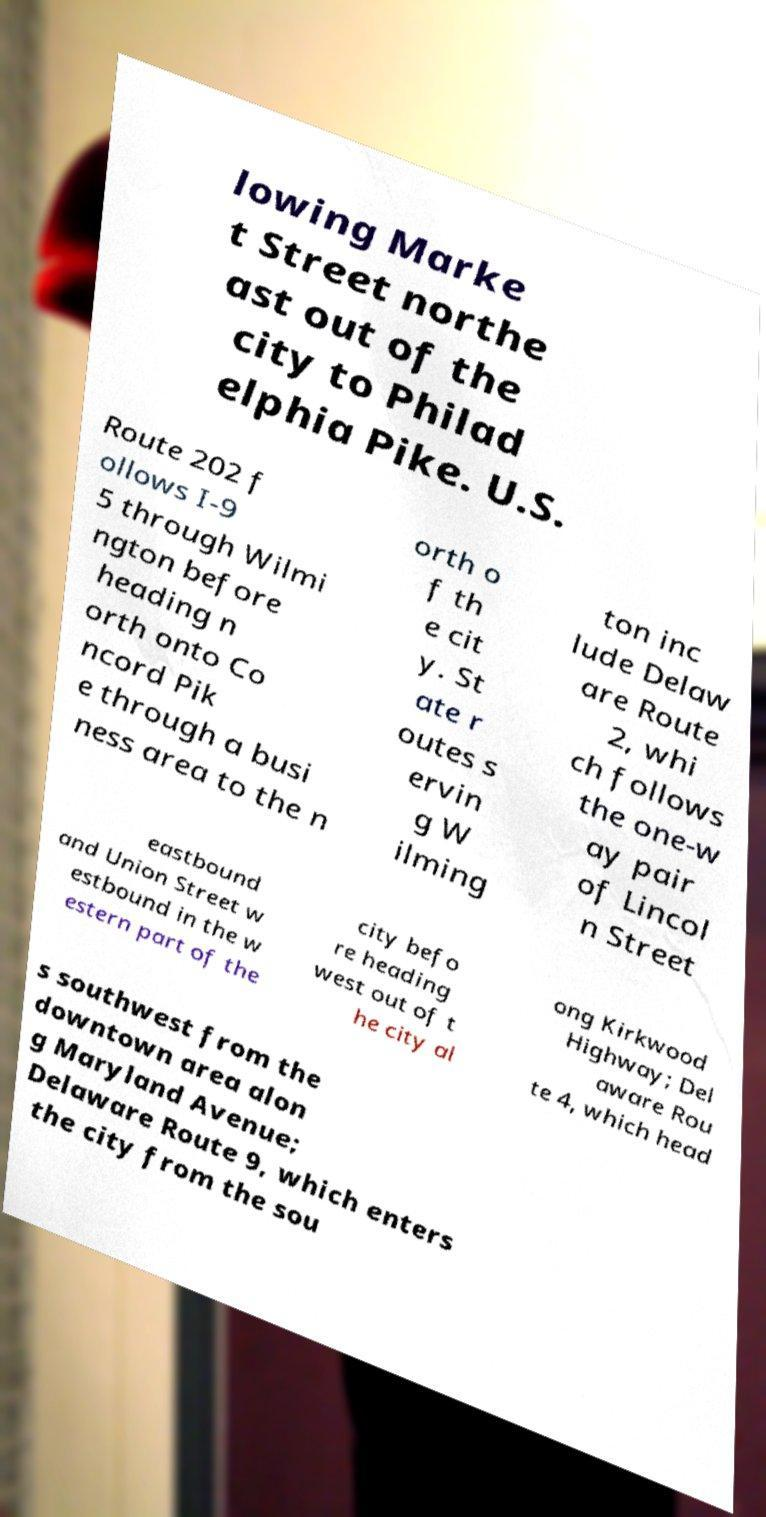Please identify and transcribe the text found in this image. lowing Marke t Street northe ast out of the city to Philad elphia Pike. U.S. Route 202 f ollows I-9 5 through Wilmi ngton before heading n orth onto Co ncord Pik e through a busi ness area to the n orth o f th e cit y. St ate r outes s ervin g W ilming ton inc lude Delaw are Route 2, whi ch follows the one-w ay pair of Lincol n Street eastbound and Union Street w estbound in the w estern part of the city befo re heading west out of t he city al ong Kirkwood Highway; Del aware Rou te 4, which head s southwest from the downtown area alon g Maryland Avenue; Delaware Route 9, which enters the city from the sou 